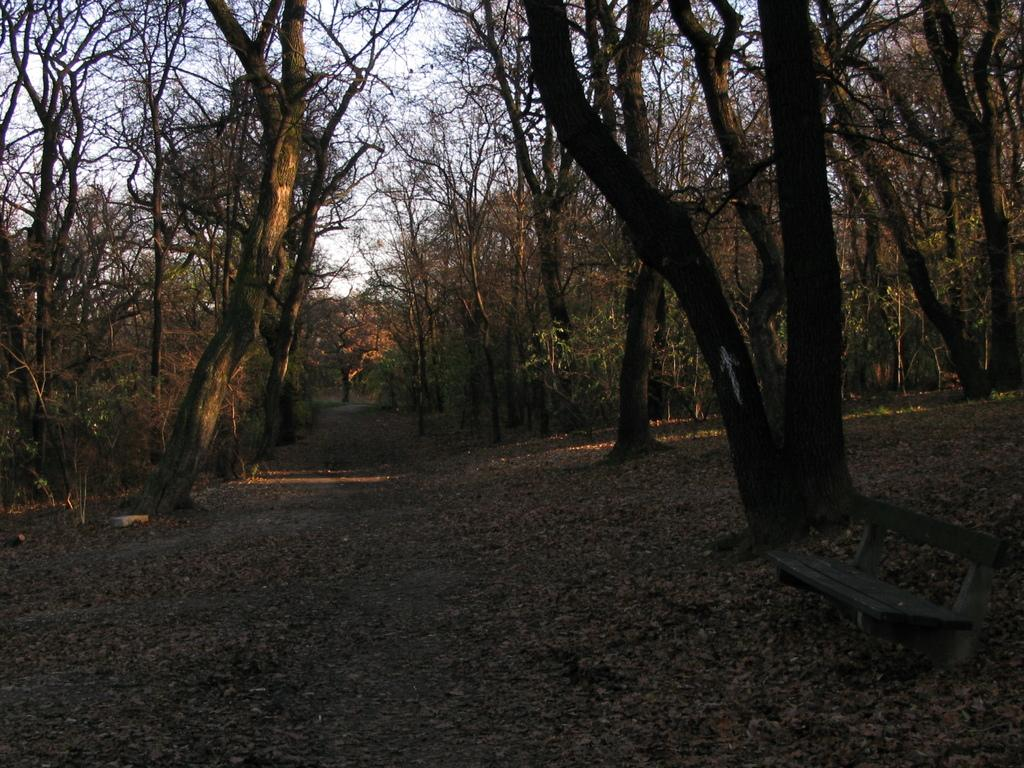What is the primary feature of the image? The primary feature of the image is the presence of many trees. What can be observed on the ground in the image? There are dried leaves on the ground in the image. What flavor of ice cream is being wished for in the image? There is no mention of ice cream or wishing for a specific flavor in the image. 